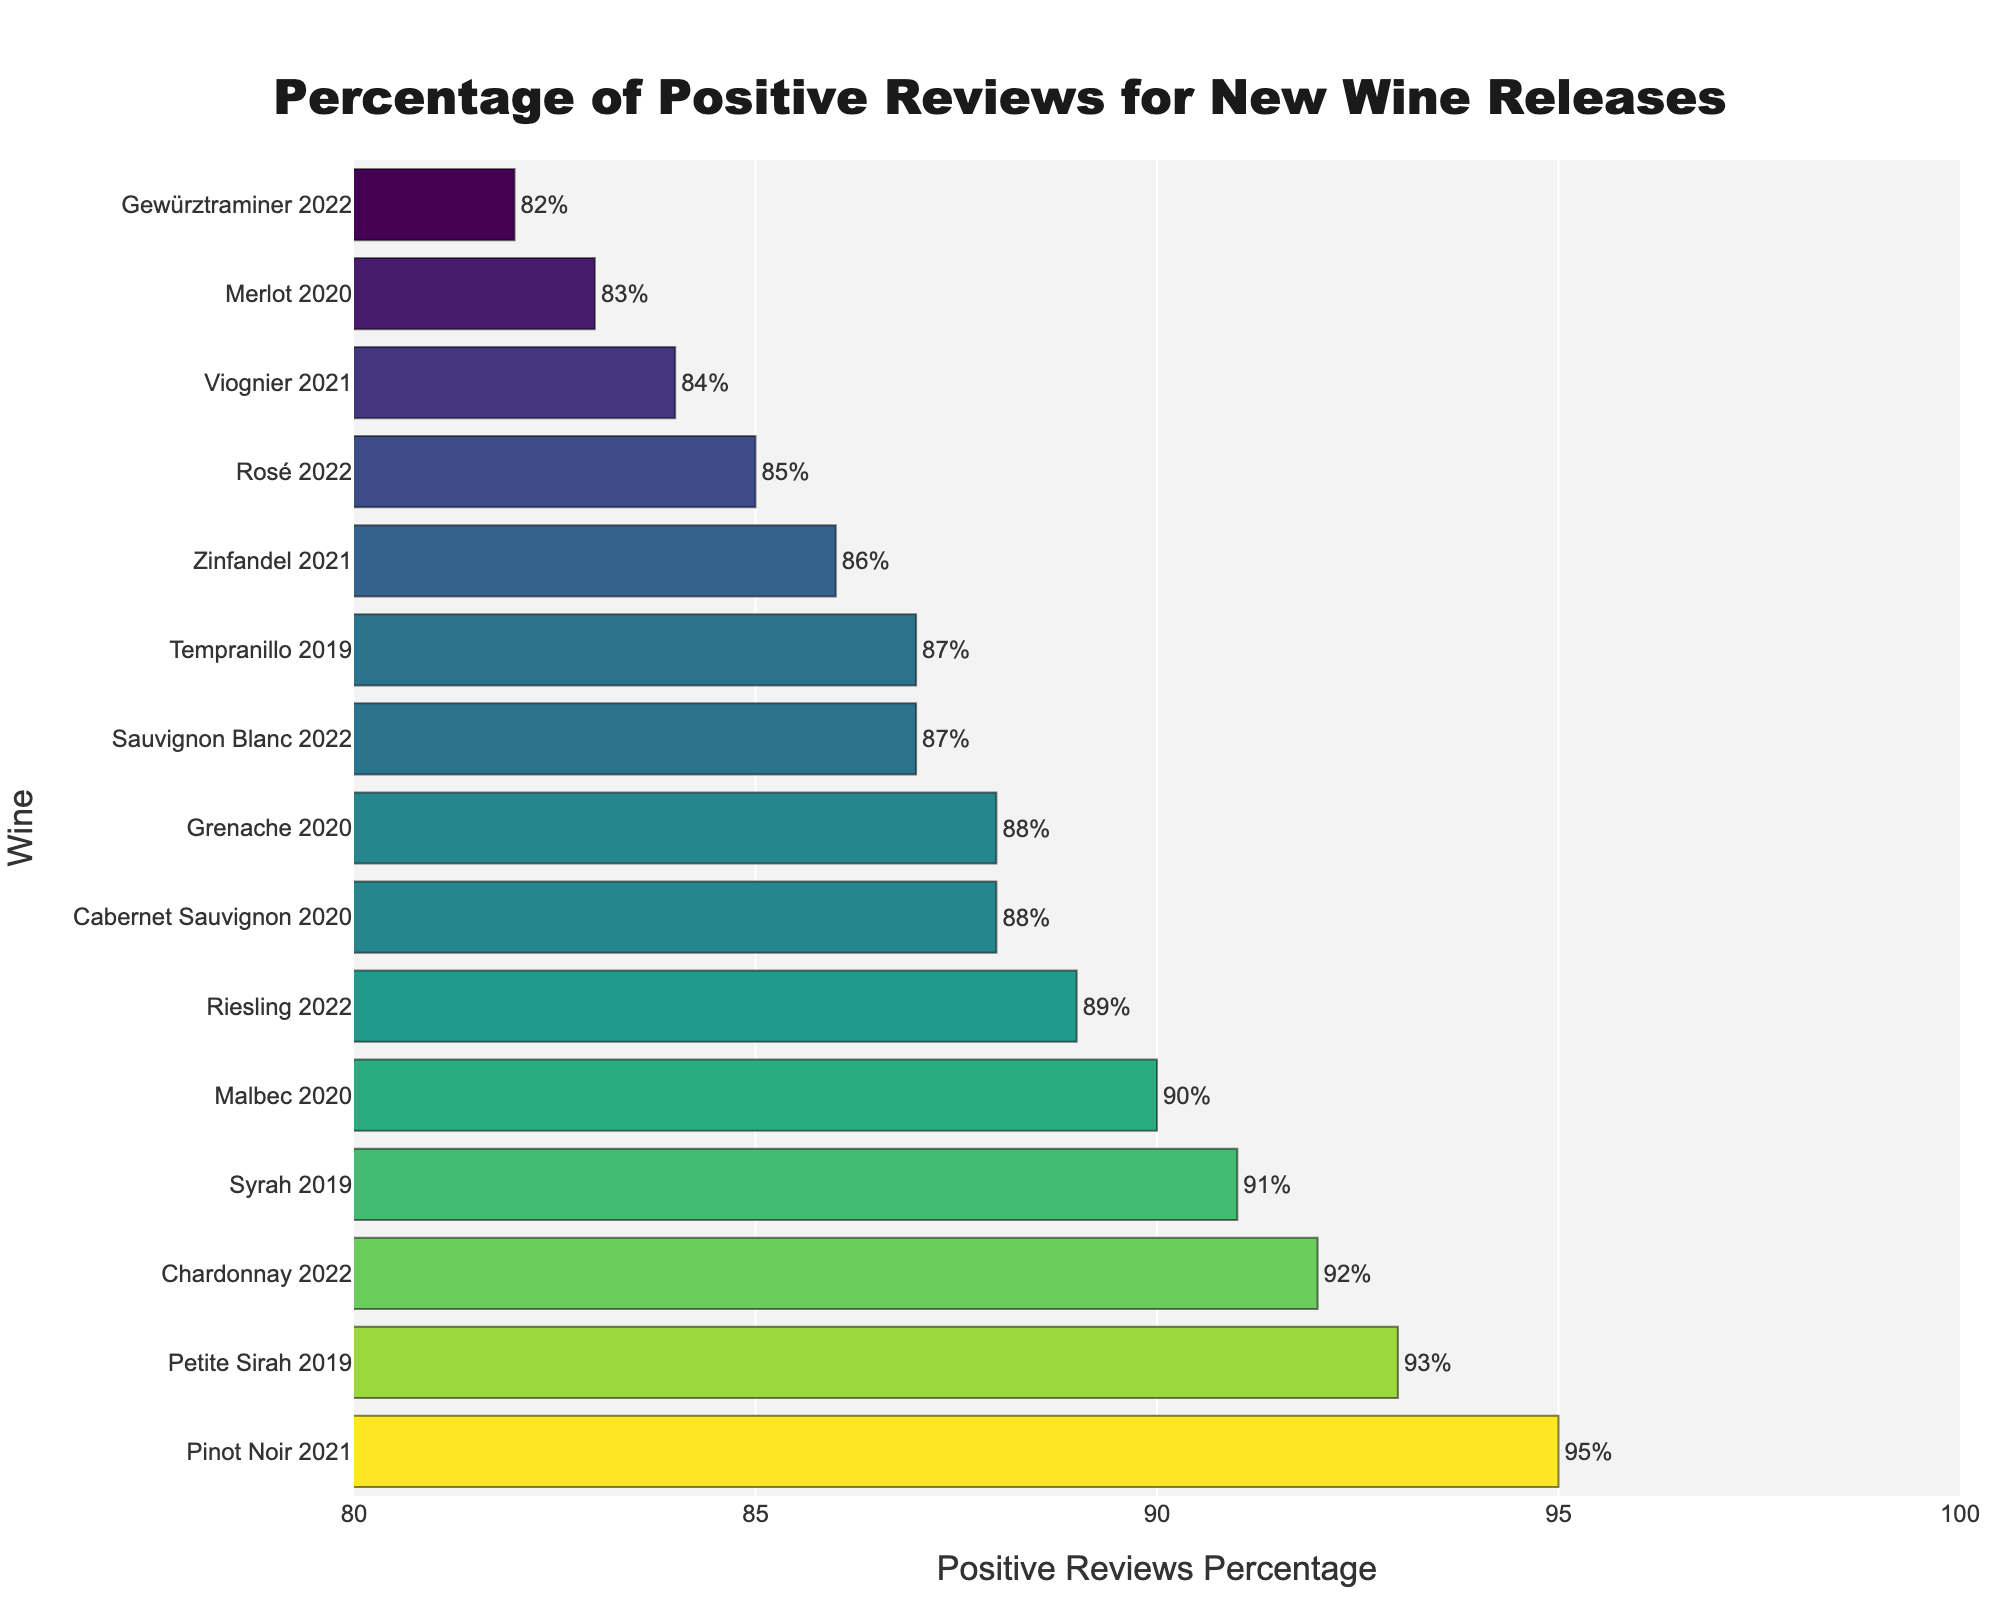Which wine received the highest percentage of positive reviews? Find the bar with the highest percentage value on the x-axis. The longest bar represents "Pinot Noir 2021" with 95% positive reviews.
Answer: Pinot Noir 2021 How many wines received at least 90% positive reviews? Count the number of bars with percentage values of 90 or higher. The wines are "Pinot Noir 2021", "Chardonnay 2022", "Petite Sirah 2019", "Syrah 2019", and "Malbec 2020", making a total of 5 wines.
Answer: 5 Which wine has a lower positive review percentage, Rosé 2022 or Zinfandel 2021? Compare the lengths of the bars for "Rosé 2022" and "Zinfandel 2021". "Rosé 2022" has 85% while "Zinfandel 2021" has 86%. Therefore, "Rosé 2022" has a lower percentage.
Answer: Rosé 2022 What is the difference in positive review percentage between the wine with the highest and lowest ratings? Find the highest percentage (95% for "Pinot Noir 2021") and the lowest percentage (82% for "Gewürztraminer 2022"), and then calculate the difference: 95% - 82% = 13%.
Answer: 13% What is the median percentage of positive reviews? List all percentages, sorted: 82, 83, 84, 85, 86, 87, 87, 88, 88, 89, 90, 91, 92, 93, 95. The median value (middle value in an ordered list) is the 8th value: 88%.
Answer: 88% Between which wines is there exactly a 5% difference in positive review percentages? Calculate the differences between the percentages. Identify the pairs that show a 5% difference. The pairs are "Cabernet Sauvignon 2020" (88%) and "Rosé 2022" (85%), and "Pinot Noir 2021" (95%) and "Syrah 2019" (91%).
Answer: Cabernet Sauvignon 2020 and Rosé 2022, Pinot Noir 2021 and Syrah 2019 Which wines have a positive review percentage between 85% and 90%? Identify the wines whose bars fall within the 85% to 90% range. These wines are "Sauvignon Blanc 2022", "Riesling 2022", "Zinfandel 2021", "Rosé 2022", "Viognier 2021", "Grenache 2020", and "Tempranillo 2019".
Answer: Sauvignon Blanc 2022, Riesling 2022, Zinfandel 2021, Rosé 2022, Viognier 2021, Grenache 2020, Tempranillo 2019 What is the average percentage of positive reviews for the wines released in 2020? Find the percentages for the 2020 releases: "Cabernet Sauvignon" (88%), "Merlot" (83%), "Malbec" (90%), and "Grenache" (88%). Calculate the average: (88 + 83 + 90 + 88) / 4 = 87.25%.
Answer: 87.25% Which wine close to the color green on the bar chart, and what is its positive review percentage? Determine which bar's color is closest to green. The "Syrah 2019" bar, with 91%, displays a color closest to green in the Viridis colorscale.
Answer: Syrah 2019, 91% Between which two wines released in 2019 is there the smallest difference in positive reviews percentage? Compare the 2019 wine percentages: "Syrah" (91%), "Petite Sirah" (93%), and "Tempranillo" (87%). The smallest difference is between "Syrah 2019" and "Petite Sirah 2019", which is 2%.
Answer: Syrah 2019 and Petite Sirah 2019 